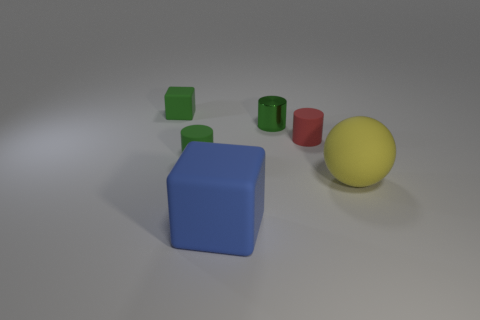Subtract all cyan spheres. How many green cylinders are left? 2 Subtract all rubber cylinders. How many cylinders are left? 1 Add 2 tiny shiny cylinders. How many objects exist? 8 Subtract all balls. How many objects are left? 5 Add 5 rubber cubes. How many rubber cubes exist? 7 Subtract 0 purple cubes. How many objects are left? 6 Subtract all gray cylinders. Subtract all brown balls. How many cylinders are left? 3 Subtract all green matte cylinders. Subtract all small yellow metallic blocks. How many objects are left? 5 Add 1 matte cylinders. How many matte cylinders are left? 3 